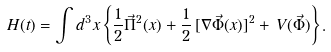Convert formula to latex. <formula><loc_0><loc_0><loc_500><loc_500>H ( t ) = \int d ^ { 3 } x \left \{ \frac { 1 } { 2 } \vec { \Pi } ^ { 2 } ( x ) + \frac { 1 } { 2 } \, [ \nabla \vec { \Phi } ( x ) ] ^ { 2 } + \, V ( \vec { \Phi } ) \right \} .</formula> 